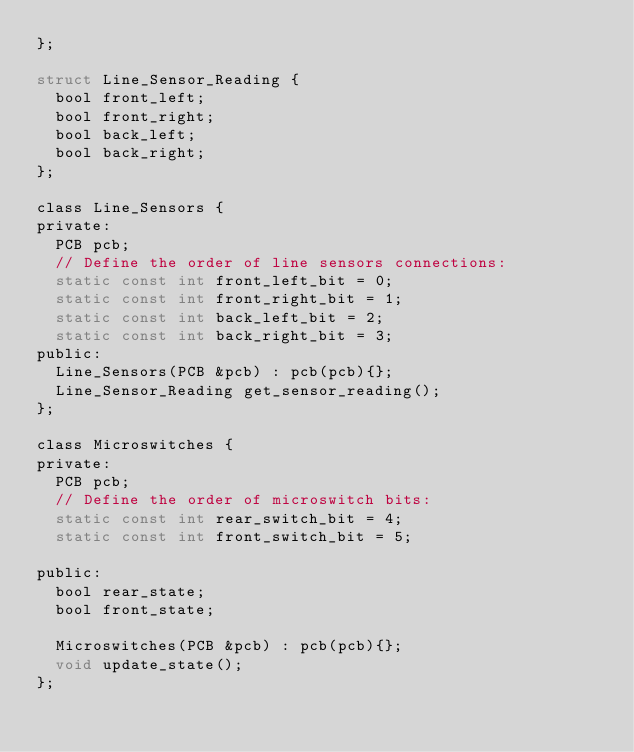Convert code to text. <code><loc_0><loc_0><loc_500><loc_500><_C_>};

struct Line_Sensor_Reading {
  bool front_left;
  bool front_right;
  bool back_left;
  bool back_right;
};

class Line_Sensors {
private:
  PCB pcb;
  // Define the order of line sensors connections:
  static const int front_left_bit = 0;
  static const int front_right_bit = 1;
  static const int back_left_bit = 2;
  static const int back_right_bit = 3;
public:
  Line_Sensors(PCB &pcb) : pcb(pcb){};
  Line_Sensor_Reading get_sensor_reading();
};

class Microswitches {
private:
  PCB pcb;
  // Define the order of microswitch bits:
  static const int rear_switch_bit = 4;
  static const int front_switch_bit = 5;

public:
  bool rear_state;
  bool front_state;

  Microswitches(PCB &pcb) : pcb(pcb){};
  void update_state();
};
</code> 